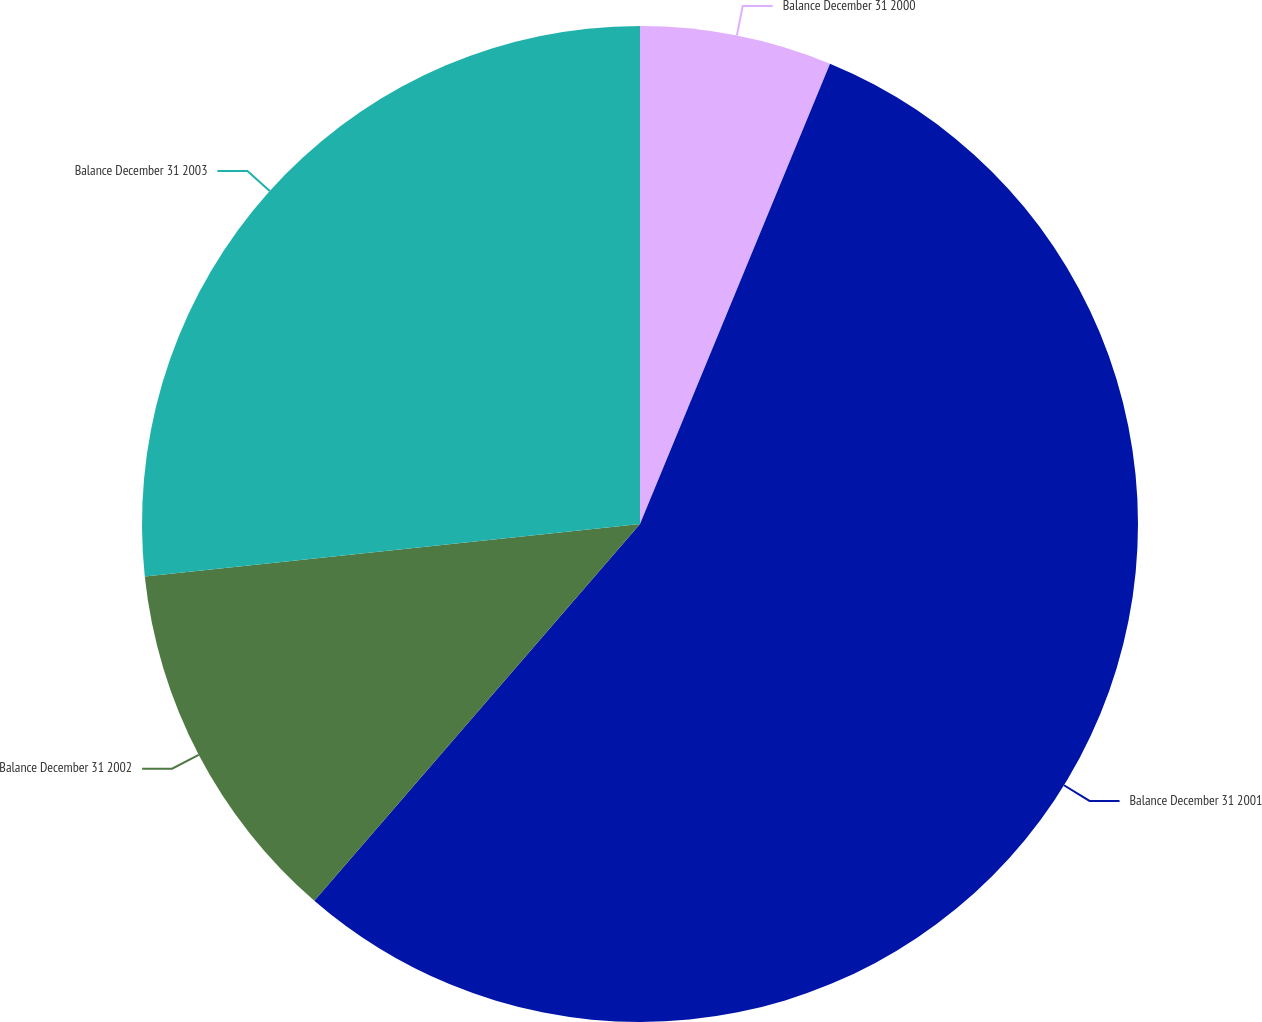<chart> <loc_0><loc_0><loc_500><loc_500><pie_chart><fcel>Balance December 31 2000<fcel>Balance December 31 2001<fcel>Balance December 31 2002<fcel>Balance December 31 2003<nl><fcel>6.23%<fcel>55.11%<fcel>11.97%<fcel>26.68%<nl></chart> 